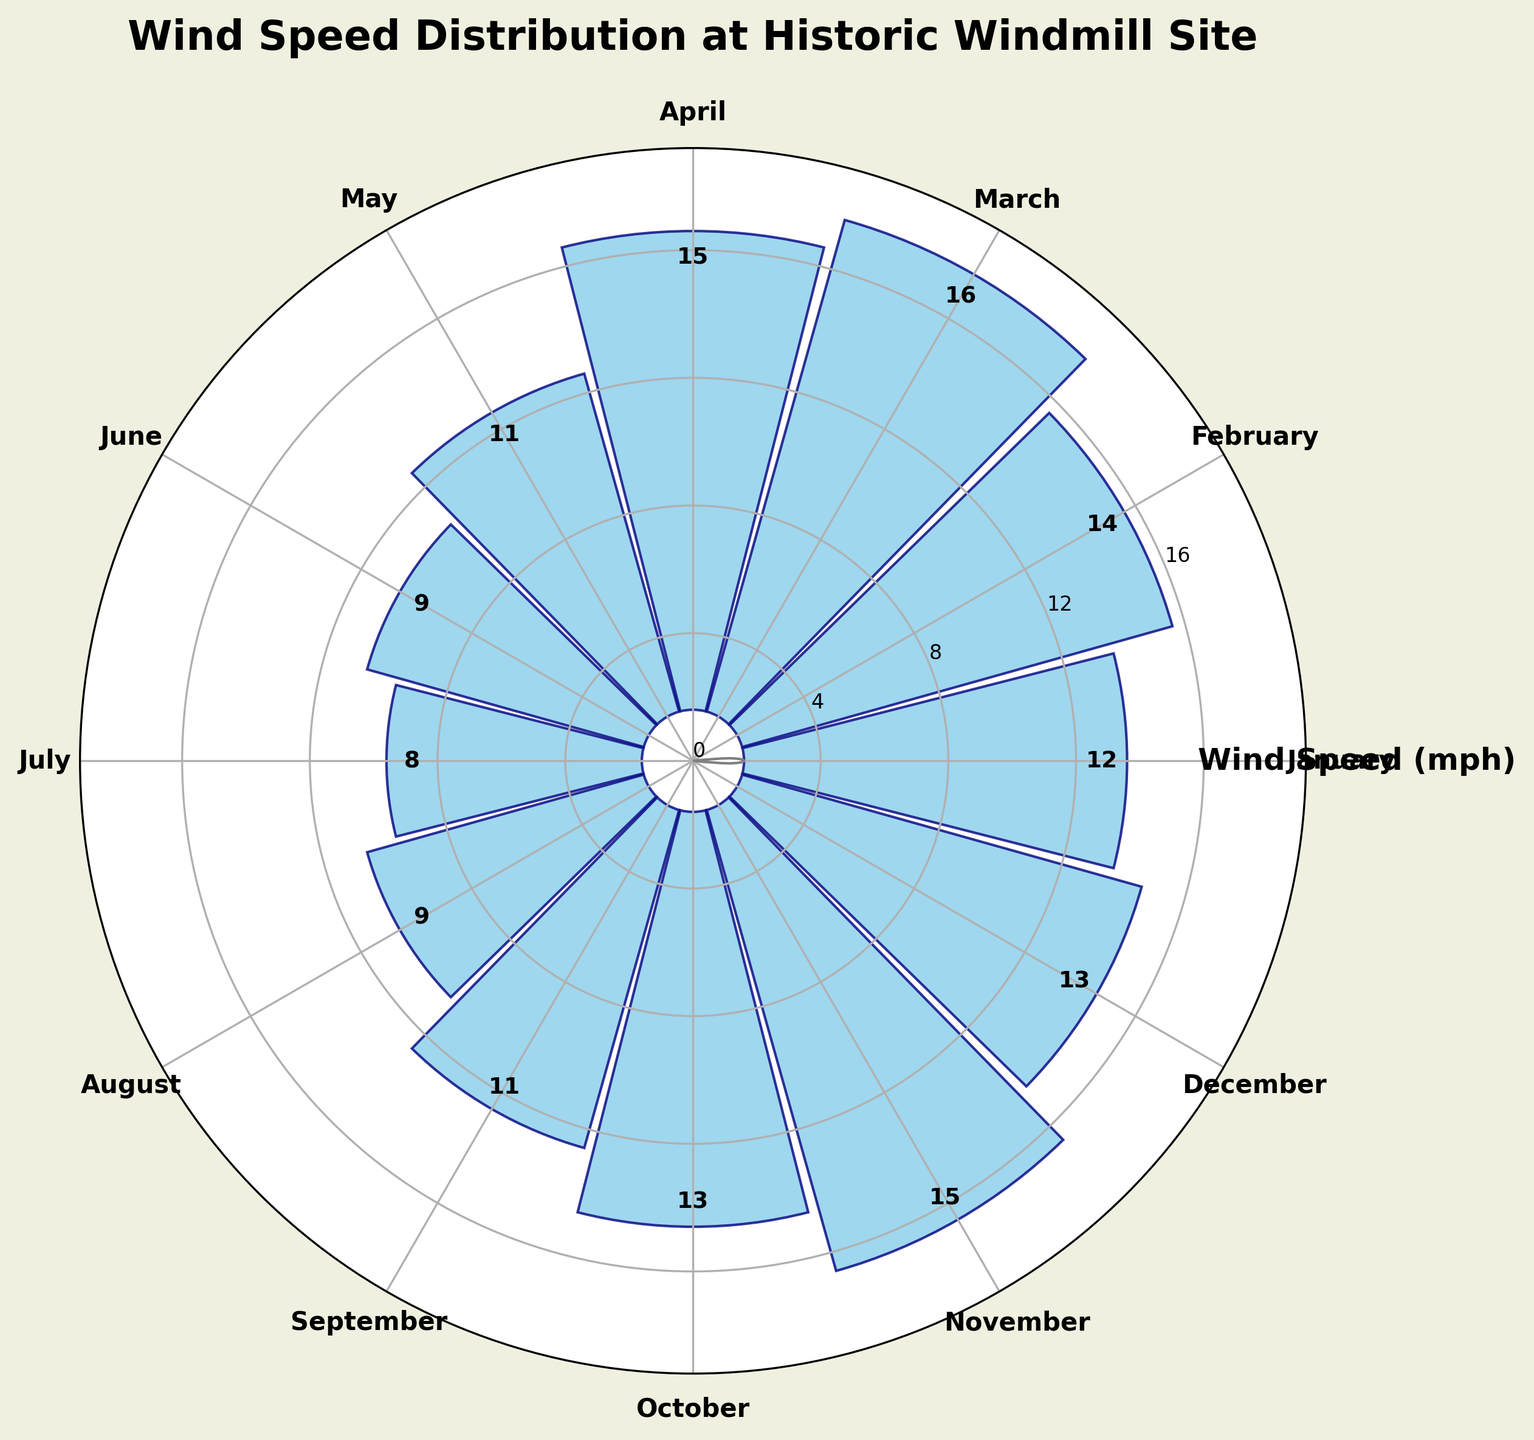What is the title of the figure? The title of the figure is displayed at the top center of the plot. It provides a quick summary of what the figure represents.
Answer: Wind Speed Distribution at Historic Windmill Site What month has the highest wind speed? The highest bar among all months indicates the peak wind speed. By observing the plot, the month with the fully extended bar has the highest speed.
Answer: March How is the wind speed distributed in July? Locate July on the circular chart and observe the height of the July bar relative to others to determine its wind speed value.
Answer: 8 mph What is the average wind speed across the year? To find the average, sum up the wind speeds for all months and divide by 12. (12+14+16+15+11+9+8+9+11+13+15+13) / 12 = 12.08
Answer: 12.08 mph Which months have wind speeds higher than 10 mph? Check the bars for each month and identify those that are higher than the reference bar indicating 10 mph.
Answer: January, February, March, April, May, September, October, November, December How does the wind speed in January compare to June? Compare the bars for January and June to see which one is taller, indicating a higher wind speed.
Answer: January is higher What are the wind speeds for the months that have the exact same readings? By checking the figure, the bars with identical heights represent the months with equal wind speed values.
Answer: June and August What is the wind speed difference between the windiest and the calmest month? Identify the tallest bar (March) and the shortest bar (July), then subtract the wind speed value of July from March. 16 - 8 = 8
Answer: 8 mph Which months have wind speeds below average? Calculate the average wind speed first (12.08 mph), then identify the bars representing months with values less than 12.08 mph.
Answer: May, June, July, August, September What is the range of wind speeds across the year? Determine the maximum and minimum wind speeds, then subtract the minimum from the maximum to find the range. 16 - 8 = 8
Answer: 8 mph 